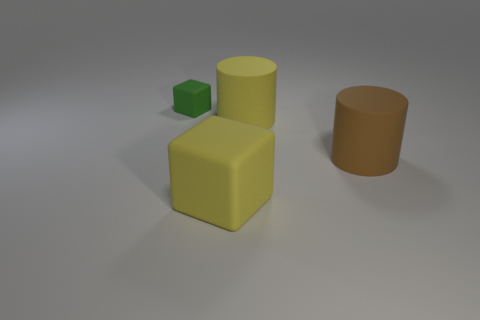How many tiny things are yellow cylinders or rubber things?
Ensure brevity in your answer.  1. Is the number of yellow matte cylinders that are in front of the brown matte thing the same as the number of green cubes that are on the left side of the tiny object?
Offer a terse response. Yes. How many other objects are there of the same color as the small block?
Your answer should be very brief. 0. There is a tiny rubber thing; is its color the same as the block that is on the right side of the small rubber thing?
Your answer should be compact. No. How many green objects are either matte cubes or small rubber blocks?
Make the answer very short. 1. Is the number of blocks that are on the right side of the tiny cube the same as the number of green objects?
Make the answer very short. Yes. Is there anything else that has the same size as the green block?
Give a very brief answer. No. What is the color of the other thing that is the same shape as the small green object?
Offer a terse response. Yellow. How many other large matte things are the same shape as the brown matte thing?
Offer a very short reply. 1. What is the material of the big cylinder that is the same color as the big cube?
Offer a very short reply. Rubber. 